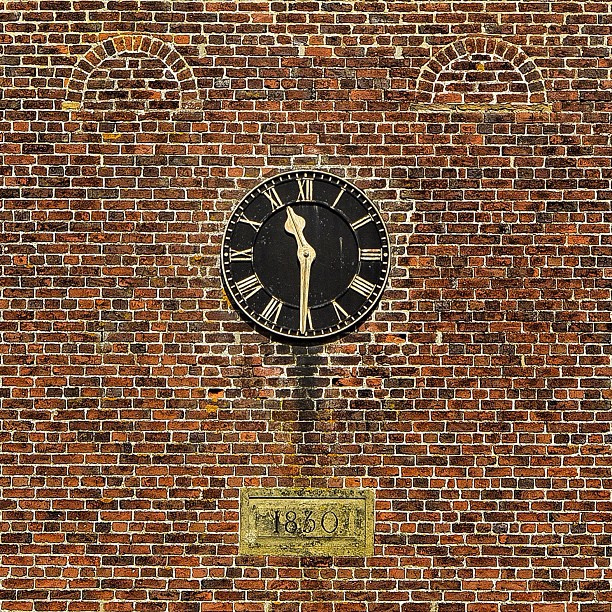Please identify all text content in this image. XII XI X I II 1830 III IIII V VI VII VIII IX 